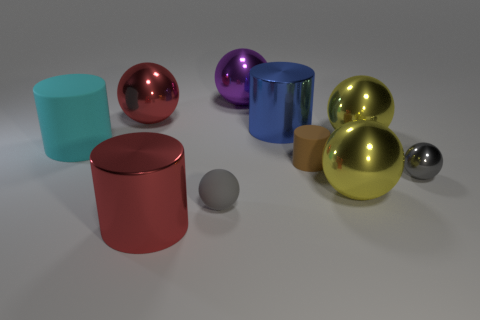What material is the big cyan object?
Provide a succinct answer. Rubber. There is a gray thing that is right of the blue metal thing; how big is it?
Ensure brevity in your answer.  Small. Does the small metallic object have the same color as the matte ball?
Keep it short and to the point. Yes. There is a thing that is the same color as the tiny metal ball; what is its material?
Give a very brief answer. Rubber. Is the number of tiny gray rubber things that are to the left of the big cyan matte thing the same as the number of red metal spheres?
Make the answer very short. No. Are there any large blue metal cylinders to the right of the tiny gray shiny sphere?
Your response must be concise. No. Does the big blue object have the same shape as the yellow thing behind the small brown cylinder?
Provide a short and direct response. No. What is the color of the tiny ball that is made of the same material as the big red cylinder?
Provide a short and direct response. Gray. What color is the big matte cylinder?
Your response must be concise. Cyan. Is the purple thing made of the same material as the gray object on the left side of the purple thing?
Offer a terse response. No. 